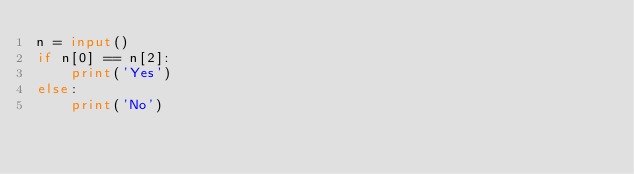<code> <loc_0><loc_0><loc_500><loc_500><_Python_>n = input()
if n[0] == n[2]:
    print('Yes')
else:
    print('No')</code> 